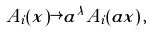Convert formula to latex. <formula><loc_0><loc_0><loc_500><loc_500>A _ { i } ( x ) \rightarrow a ^ { \lambda } A _ { i } ( a x ) \, ,</formula> 